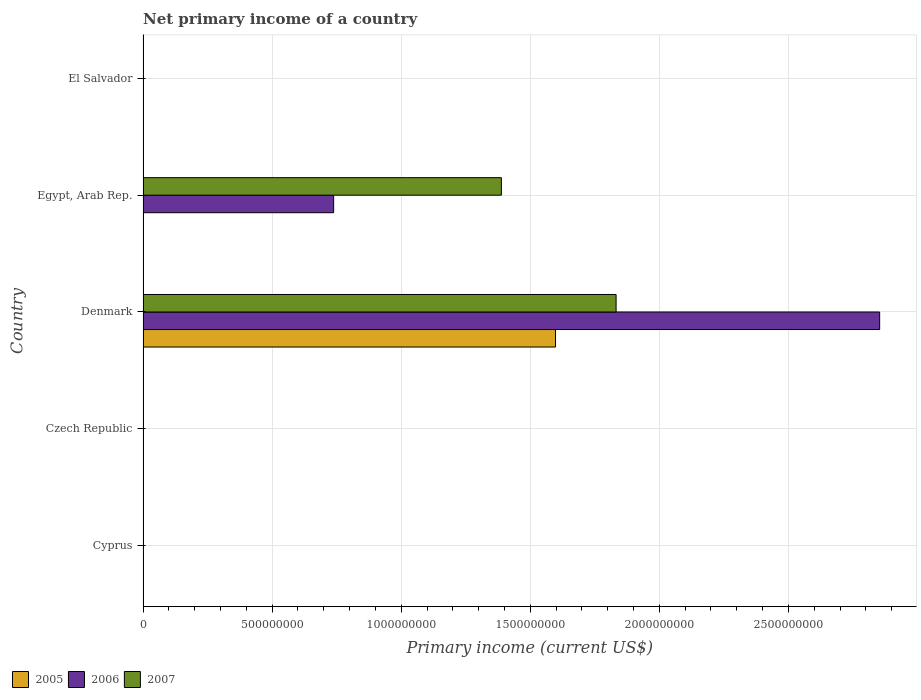How many different coloured bars are there?
Ensure brevity in your answer.  3. What is the label of the 2nd group of bars from the top?
Provide a succinct answer. Egypt, Arab Rep. What is the primary income in 2007 in El Salvador?
Keep it short and to the point. 0. Across all countries, what is the maximum primary income in 2005?
Give a very brief answer. 1.60e+09. In which country was the primary income in 2005 maximum?
Make the answer very short. Denmark. What is the total primary income in 2005 in the graph?
Your response must be concise. 1.60e+09. What is the difference between the primary income in 2007 in Denmark and that in Egypt, Arab Rep.?
Your answer should be compact. 4.44e+08. What is the difference between the primary income in 2007 in El Salvador and the primary income in 2006 in Egypt, Arab Rep.?
Make the answer very short. -7.38e+08. What is the average primary income in 2005 per country?
Provide a short and direct response. 3.20e+08. What is the difference between the primary income in 2005 and primary income in 2007 in Denmark?
Keep it short and to the point. -2.35e+08. What is the difference between the highest and the lowest primary income in 2007?
Make the answer very short. 1.83e+09. In how many countries, is the primary income in 2007 greater than the average primary income in 2007 taken over all countries?
Ensure brevity in your answer.  2. Is the sum of the primary income in 2006 in Denmark and Egypt, Arab Rep. greater than the maximum primary income in 2007 across all countries?
Give a very brief answer. Yes. How many bars are there?
Offer a very short reply. 5. Does the graph contain grids?
Make the answer very short. Yes. Where does the legend appear in the graph?
Keep it short and to the point. Bottom left. What is the title of the graph?
Ensure brevity in your answer.  Net primary income of a country. What is the label or title of the X-axis?
Your response must be concise. Primary income (current US$). What is the Primary income (current US$) of 2007 in Czech Republic?
Provide a short and direct response. 0. What is the Primary income (current US$) in 2005 in Denmark?
Offer a very short reply. 1.60e+09. What is the Primary income (current US$) in 2006 in Denmark?
Ensure brevity in your answer.  2.85e+09. What is the Primary income (current US$) of 2007 in Denmark?
Provide a succinct answer. 1.83e+09. What is the Primary income (current US$) of 2005 in Egypt, Arab Rep.?
Make the answer very short. 0. What is the Primary income (current US$) of 2006 in Egypt, Arab Rep.?
Your answer should be compact. 7.38e+08. What is the Primary income (current US$) of 2007 in Egypt, Arab Rep.?
Offer a very short reply. 1.39e+09. What is the Primary income (current US$) in 2005 in El Salvador?
Offer a very short reply. 0. What is the Primary income (current US$) of 2006 in El Salvador?
Offer a very short reply. 0. What is the Primary income (current US$) in 2007 in El Salvador?
Offer a terse response. 0. Across all countries, what is the maximum Primary income (current US$) in 2005?
Keep it short and to the point. 1.60e+09. Across all countries, what is the maximum Primary income (current US$) of 2006?
Offer a terse response. 2.85e+09. Across all countries, what is the maximum Primary income (current US$) of 2007?
Make the answer very short. 1.83e+09. What is the total Primary income (current US$) in 2005 in the graph?
Your response must be concise. 1.60e+09. What is the total Primary income (current US$) in 2006 in the graph?
Keep it short and to the point. 3.59e+09. What is the total Primary income (current US$) in 2007 in the graph?
Your answer should be very brief. 3.22e+09. What is the difference between the Primary income (current US$) in 2006 in Denmark and that in Egypt, Arab Rep.?
Offer a terse response. 2.12e+09. What is the difference between the Primary income (current US$) of 2007 in Denmark and that in Egypt, Arab Rep.?
Your answer should be compact. 4.44e+08. What is the difference between the Primary income (current US$) of 2005 in Denmark and the Primary income (current US$) of 2006 in Egypt, Arab Rep.?
Offer a terse response. 8.60e+08. What is the difference between the Primary income (current US$) in 2005 in Denmark and the Primary income (current US$) in 2007 in Egypt, Arab Rep.?
Your answer should be very brief. 2.10e+08. What is the difference between the Primary income (current US$) of 2006 in Denmark and the Primary income (current US$) of 2007 in Egypt, Arab Rep.?
Offer a very short reply. 1.47e+09. What is the average Primary income (current US$) of 2005 per country?
Offer a terse response. 3.20e+08. What is the average Primary income (current US$) in 2006 per country?
Your response must be concise. 7.18e+08. What is the average Primary income (current US$) in 2007 per country?
Your answer should be compact. 6.44e+08. What is the difference between the Primary income (current US$) of 2005 and Primary income (current US$) of 2006 in Denmark?
Offer a terse response. -1.26e+09. What is the difference between the Primary income (current US$) of 2005 and Primary income (current US$) of 2007 in Denmark?
Provide a short and direct response. -2.35e+08. What is the difference between the Primary income (current US$) of 2006 and Primary income (current US$) of 2007 in Denmark?
Ensure brevity in your answer.  1.02e+09. What is the difference between the Primary income (current US$) in 2006 and Primary income (current US$) in 2007 in Egypt, Arab Rep.?
Your response must be concise. -6.50e+08. What is the ratio of the Primary income (current US$) of 2006 in Denmark to that in Egypt, Arab Rep.?
Provide a succinct answer. 3.87. What is the ratio of the Primary income (current US$) in 2007 in Denmark to that in Egypt, Arab Rep.?
Keep it short and to the point. 1.32. What is the difference between the highest and the lowest Primary income (current US$) of 2005?
Keep it short and to the point. 1.60e+09. What is the difference between the highest and the lowest Primary income (current US$) in 2006?
Your answer should be compact. 2.85e+09. What is the difference between the highest and the lowest Primary income (current US$) in 2007?
Make the answer very short. 1.83e+09. 